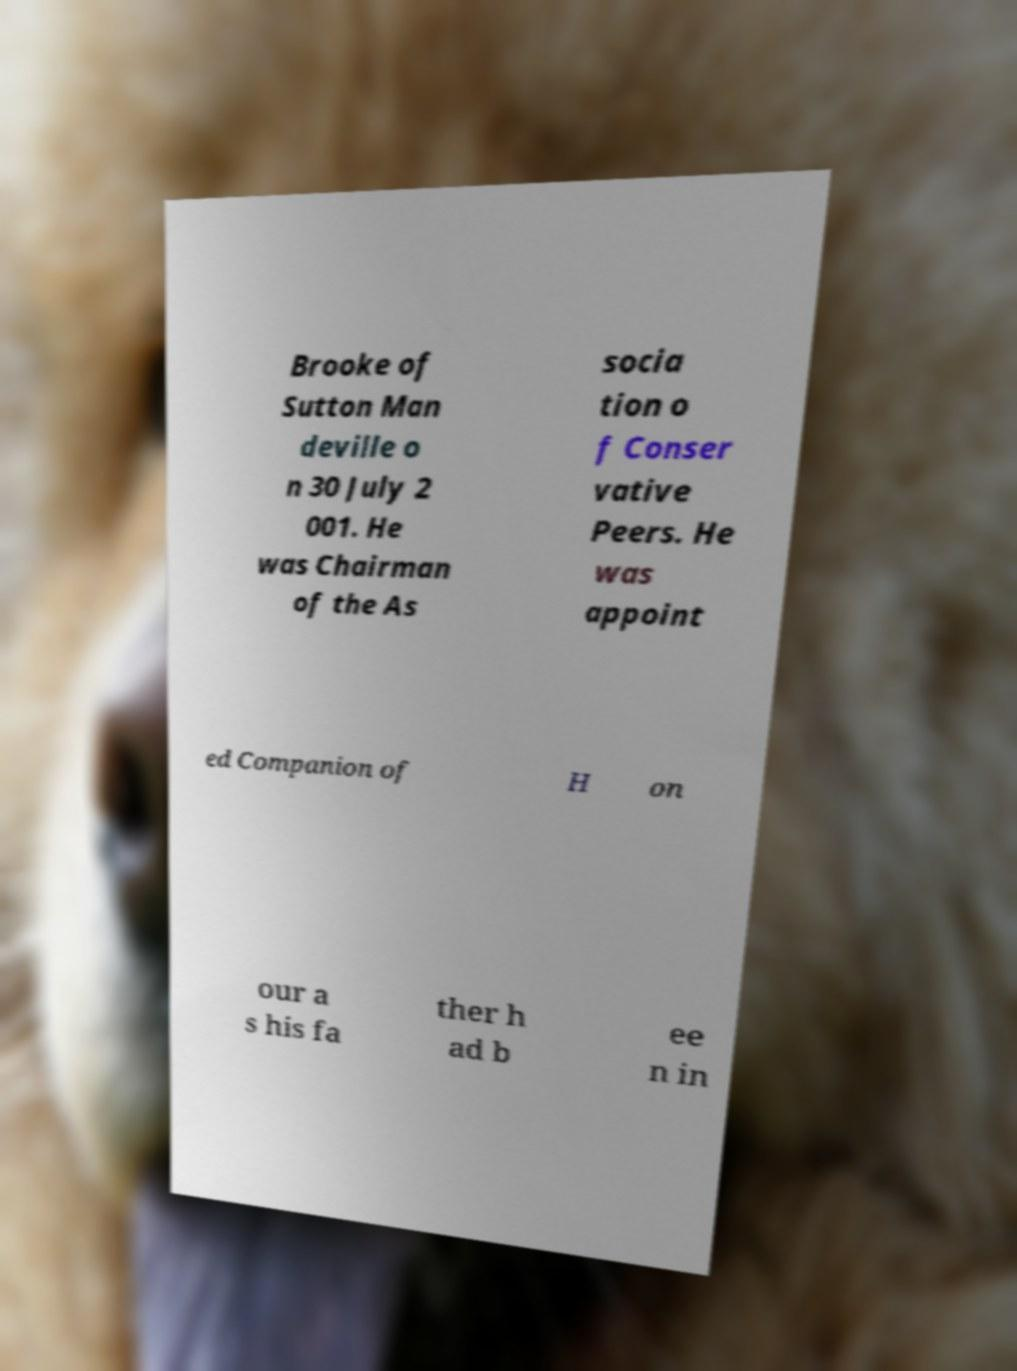There's text embedded in this image that I need extracted. Can you transcribe it verbatim? Brooke of Sutton Man deville o n 30 July 2 001. He was Chairman of the As socia tion o f Conser vative Peers. He was appoint ed Companion of H on our a s his fa ther h ad b ee n in 